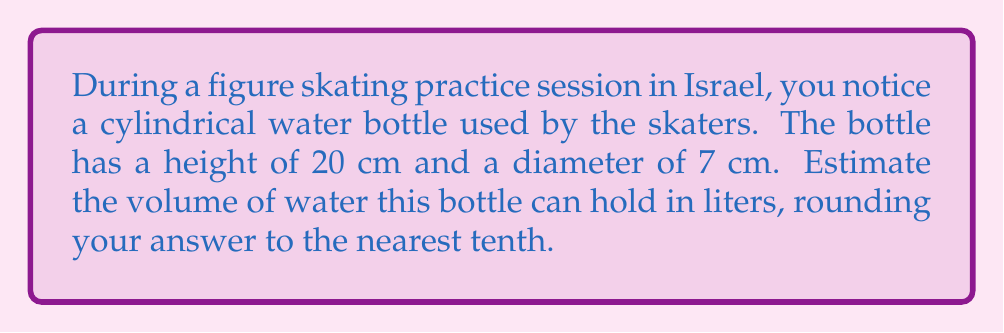Give your solution to this math problem. To estimate the volume of the cylindrical water bottle, we'll follow these steps:

1) The formula for the volume of a cylinder is:
   $$V = \pi r^2 h$$
   where $r$ is the radius of the base and $h$ is the height.

2) We're given the diameter (7 cm), so we need to calculate the radius:
   $$r = \frac{7\text{ cm}}{2} = 3.5\text{ cm}$$

3) Now we can substitute the values into our formula:
   $$V = \pi (3.5\text{ cm})^2 (20\text{ cm})$$

4) Let's calculate:
   $$V = \pi (12.25\text{ cm}^2) (20\text{ cm})$$
   $$V = 769.69\text{ cm}^3$$

5) To convert cubic centimeters to liters:
   $$769.69\text{ cm}^3 \times \frac{1\text{ L}}{1000\text{ cm}^3} = 0.76969\text{ L}$$

6) Rounding to the nearest tenth:
   $$0.76969\text{ L} \approx 0.8\text{ L}$$

Therefore, the estimated volume of the water bottle is 0.8 liters.
Answer: 0.8 L 